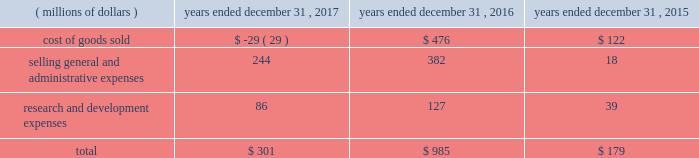Between the actual return on plan assets compared to the expected return on plan assets ( u.s .
Pension plans had an actual rate of return of 7.8 percent compared to an expected rate of return of 6.9 percent ) .
2022 2015 net mark-to-market loss of $ 179 million - primarily due to the difference between the actual return on plan assets compared to the expected return on plan assets ( u.s .
Pension plans had an actual rate of return of ( 2.0 ) percent compared to an expected rate of return of 7.4 percent ) which was partially offset by higher discount rates at the end of 2015 compared to 2014 .
The net mark-to-market losses were in the following results of operations line items: .
Effective january 1 , 2018 , we adopted new accounting guidance issued by the fasb related to the presentation of net periodic pension and opeb costs .
This guidance requires that an employer disaggregate the service cost component from the other components of net benefit cost .
Service cost is required to be reported in the same line item or items as other compensation costs arising from services rendered by the pertinent employees during the period .
The other components of net benefit cost are required to be reported outside the subtotal for income from operations .
As a result , components of pension and opeb costs , other than service costs , will be reclassified from operating costs to other income/expense .
This change will be applied retrospectively to prior years .
In the fourth quarter of 2017 , the company reviewed and made changes to the mortality assumptions primarily for our u.s .
Pension plans which resulted in an overall increase in the life expectancy of plan participants .
As of december 31 , 2017 these changes resulted in an increase in our liability for postemployment benefits of approximately $ 290 million .
In the fourth quarter of 2016 , the company adopted new mortality improvement scales released by the soa for our u.s .
Pension and opeb plans .
As of december 31 , 2016 , this resulted in an increase in our liability for postemployment benefits of approximately $ 200 million .
In the first quarter of 2017 , we announced the closure of our gosselies , belgium facility .
This announcement impacted certain employees that participated in a defined benefit pension plan and resulted in a curtailment and the recognition of termination benefits .
In march 2017 , we recognized a net loss of $ 20 million for the curtailment and termination benefits .
In addition , we announced the decision to phase out production at our aurora , illinois , facility , which resulted in termination benefits of $ 9 million for certain hourly employees that participate in our u.s .
Hourly defined benefit pension plan .
Beginning in 2016 , we elected to utilize a full yield curve approach in the estimation of service and interest costs by applying the specific spot rates along the yield curve used in the determination of the benefit obligation to the relevant projected cash flows .
Service and interest costs in 2017 and 2016 were lower by $ 140 million and $ 180 million , respectively , under the new method than they would have been under the previous method .
This change had no impact on our year-end defined benefit pension and opeb obligations or our annual net periodic benefit cost as the lower service and interest costs were entirely offset in the actuarial loss ( gain ) reported for the respective year .
We expect our total defined benefit pension and opeb expense ( excluding the impact of mark-to-market gains and losses ) to decrease approximately $ 80 million in 2018 .
This decrease is primarily due to a higher expected return on plan assets as a result of a higher asset base in 2018 .
In general , our strategy for both the u.s .
And the non-u.s .
Pensions includes ongoing alignment of our investments to our liabilities , while reducing risk in our portfolio .
For our u.s .
Pension plans , our year-end 2017 asset allocation was 34 a0percent equities , 62 a0percent fixed income and 4 percent other .
Our current u.s .
Pension target asset allocation is 30 percent equities and 70 percent fixed income .
The target allocation is revisited periodically to ensure it reflects our overall objectives .
The u.s .
Plans are rebalanced to plus or minus 5 percentage points of the target asset allocation ranges on a monthly basis .
The year-end 2017 asset allocation for our non-u.s .
Pension plans was 40 a0percent equities , 53 a0percent fixed income , 4 a0percent real estate and 3 percent other .
The 2017 weighted-average target allocations for our non-u.s .
Pension plans was 38 a0percent equities , 54 a0percent fixed income , 5 a0percent real estate and 3 a0percent other .
The target allocations for each plan vary based upon local statutory requirements , demographics of the plan participants and funded status .
The frequency of rebalancing for the non-u.s .
Plans varies depending on the plan .
Contributions to our pension and opeb plans were $ 1.6 billion and $ 329 million in 2017 and 2016 , respectively .
The 2017 contributions include a $ 1.0 billion discretionary contribution made to our u.s .
Pension plans in december 2017 .
We expect to make approximately $ 365 million of contributions to our pension and opeb plans in 2018 .
We believe we have adequate resources to fund both pension and opeb plans .
48 | 2017 form 10-k .
What portion of the net mark-to-market loss were driven by cost of good sold in 2016? 
Computations: (476 / 985)
Answer: 0.48325. 